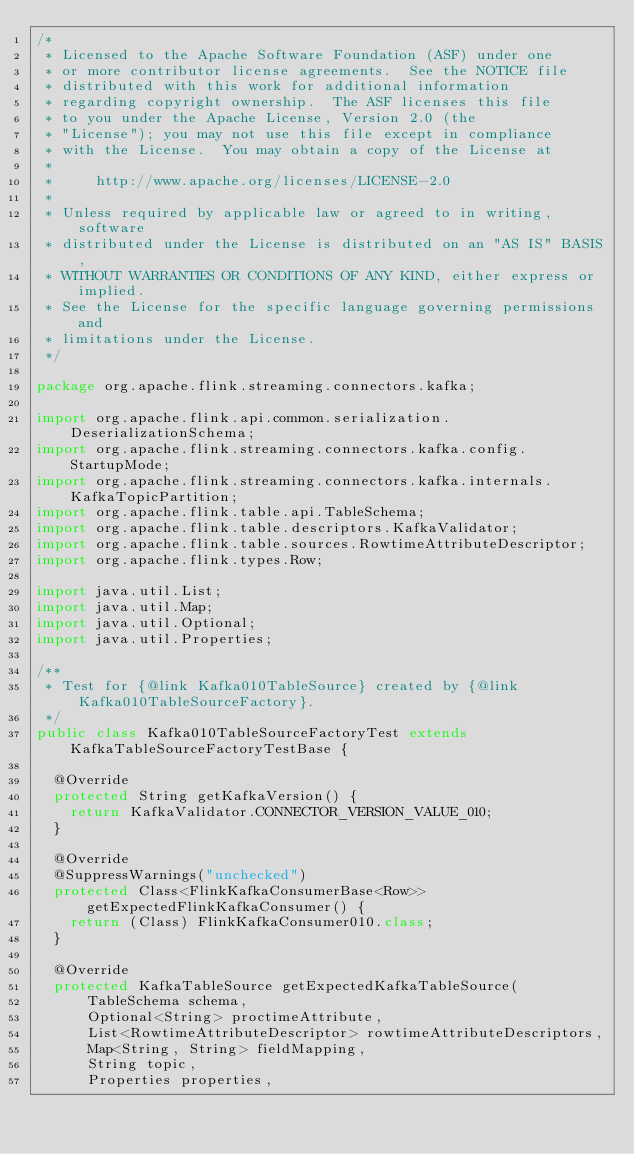Convert code to text. <code><loc_0><loc_0><loc_500><loc_500><_Java_>/*
 * Licensed to the Apache Software Foundation (ASF) under one
 * or more contributor license agreements.  See the NOTICE file
 * distributed with this work for additional information
 * regarding copyright ownership.  The ASF licenses this file
 * to you under the Apache License, Version 2.0 (the
 * "License"); you may not use this file except in compliance
 * with the License.  You may obtain a copy of the License at
 *
 *     http://www.apache.org/licenses/LICENSE-2.0
 *
 * Unless required by applicable law or agreed to in writing, software
 * distributed under the License is distributed on an "AS IS" BASIS,
 * WITHOUT WARRANTIES OR CONDITIONS OF ANY KIND, either express or implied.
 * See the License for the specific language governing permissions and
 * limitations under the License.
 */

package org.apache.flink.streaming.connectors.kafka;

import org.apache.flink.api.common.serialization.DeserializationSchema;
import org.apache.flink.streaming.connectors.kafka.config.StartupMode;
import org.apache.flink.streaming.connectors.kafka.internals.KafkaTopicPartition;
import org.apache.flink.table.api.TableSchema;
import org.apache.flink.table.descriptors.KafkaValidator;
import org.apache.flink.table.sources.RowtimeAttributeDescriptor;
import org.apache.flink.types.Row;

import java.util.List;
import java.util.Map;
import java.util.Optional;
import java.util.Properties;

/**
 * Test for {@link Kafka010TableSource} created by {@link Kafka010TableSourceFactory}.
 */
public class Kafka010TableSourceFactoryTest extends KafkaTableSourceFactoryTestBase {

	@Override
	protected String getKafkaVersion() {
		return KafkaValidator.CONNECTOR_VERSION_VALUE_010;
	}

	@Override
	@SuppressWarnings("unchecked")
	protected Class<FlinkKafkaConsumerBase<Row>> getExpectedFlinkKafkaConsumer() {
		return (Class) FlinkKafkaConsumer010.class;
	}

	@Override
	protected KafkaTableSource getExpectedKafkaTableSource(
			TableSchema schema,
			Optional<String> proctimeAttribute,
			List<RowtimeAttributeDescriptor> rowtimeAttributeDescriptors,
			Map<String, String> fieldMapping,
			String topic,
			Properties properties,</code> 